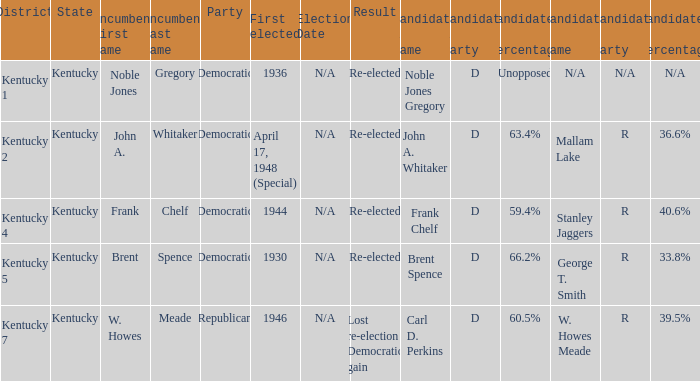Which party won in the election in voting district Kentucky 5? Democratic. 